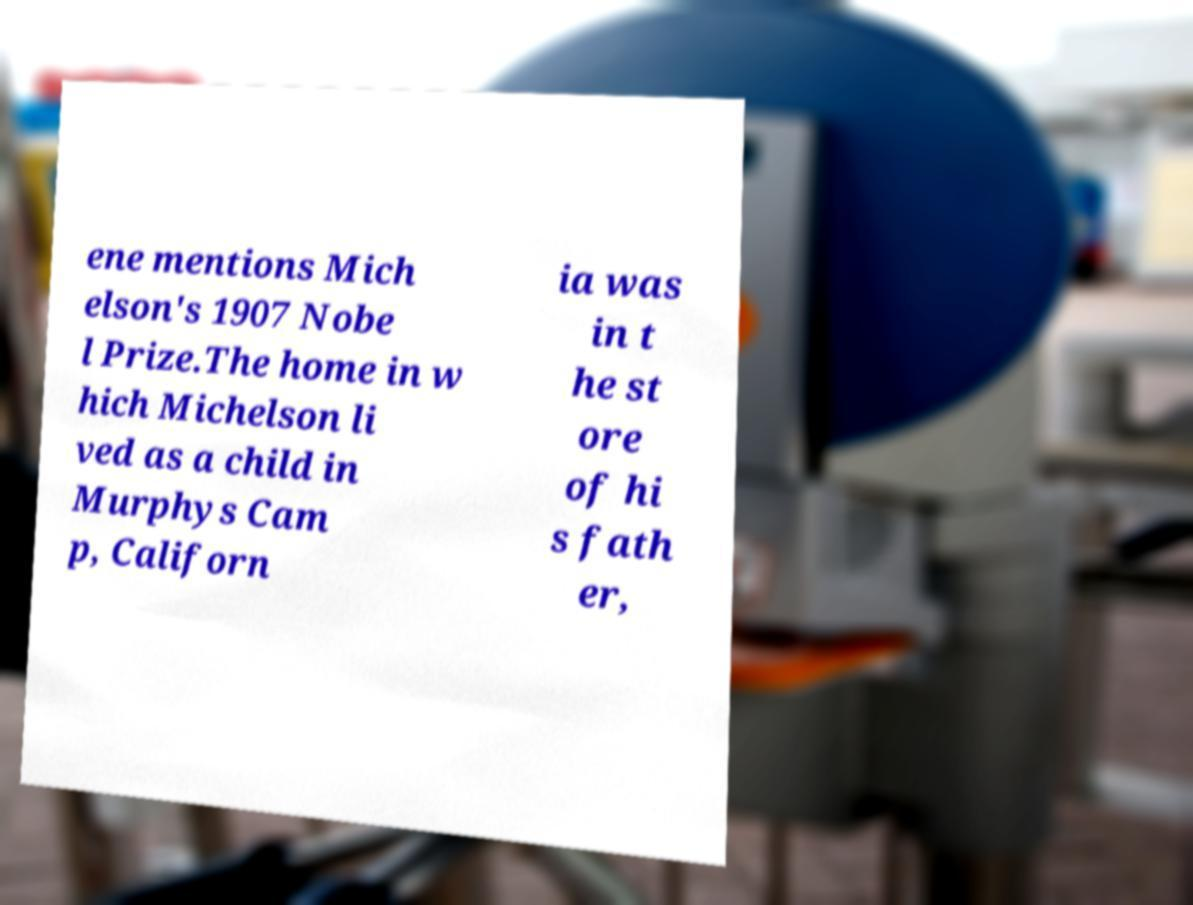For documentation purposes, I need the text within this image transcribed. Could you provide that? ene mentions Mich elson's 1907 Nobe l Prize.The home in w hich Michelson li ved as a child in Murphys Cam p, Californ ia was in t he st ore of hi s fath er, 